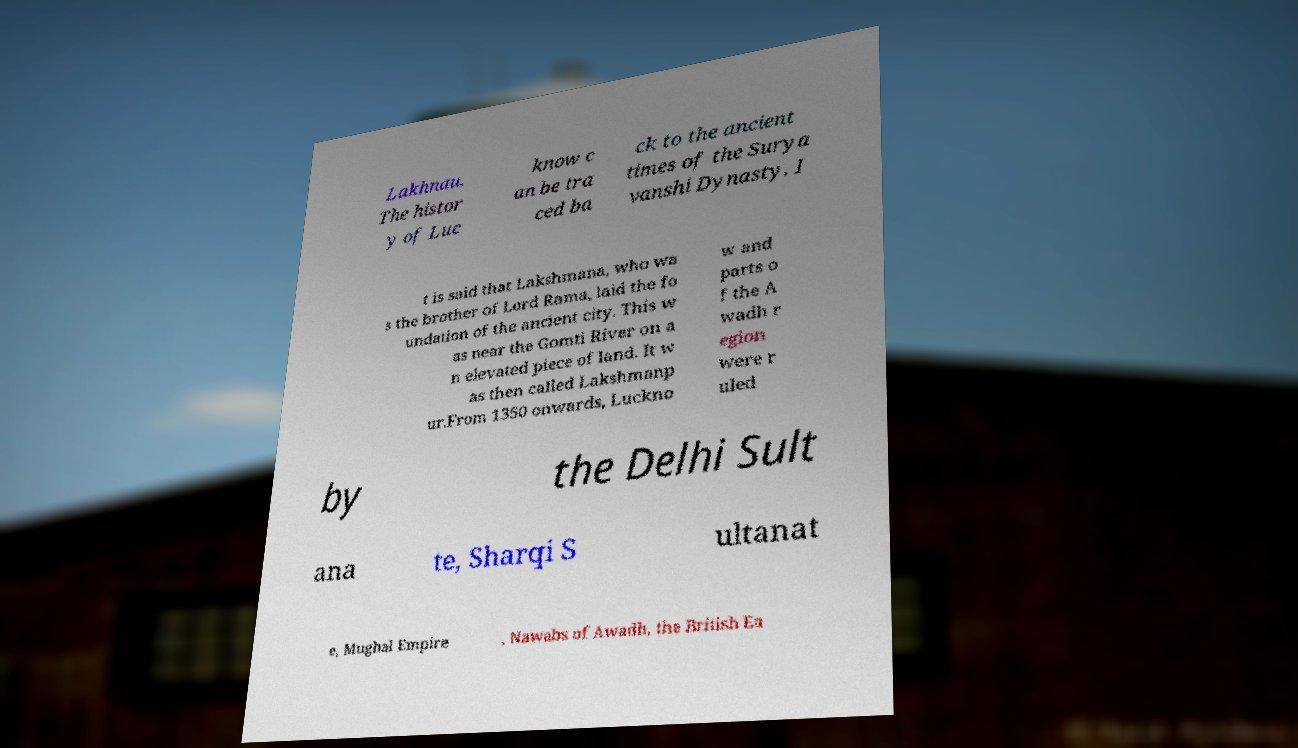Please identify and transcribe the text found in this image. Lakhnau. The histor y of Luc know c an be tra ced ba ck to the ancient times of the Surya vanshi Dynasty. I t is said that Lakshmana, who wa s the brother of Lord Rama, laid the fo undation of the ancient city. This w as near the Gomti River on a n elevated piece of land. It w as then called Lakshmanp ur.From 1350 onwards, Luckno w and parts o f the A wadh r egion were r uled by the Delhi Sult ana te, Sharqi S ultanat e, Mughal Empire , Nawabs of Awadh, the British Ea 